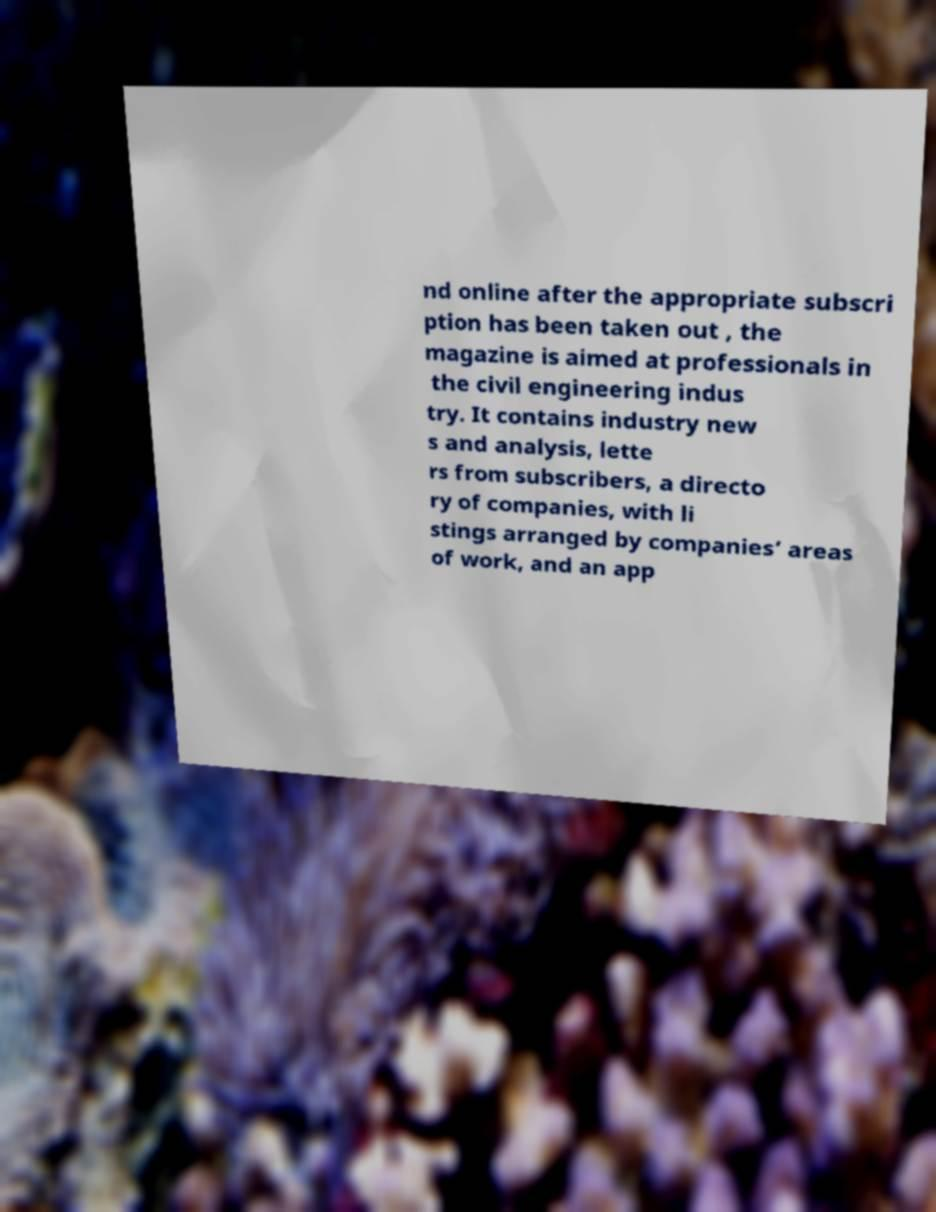There's text embedded in this image that I need extracted. Can you transcribe it verbatim? nd online after the appropriate subscri ption has been taken out , the magazine is aimed at professionals in the civil engineering indus try. It contains industry new s and analysis, lette rs from subscribers, a directo ry of companies, with li stings arranged by companies’ areas of work, and an app 